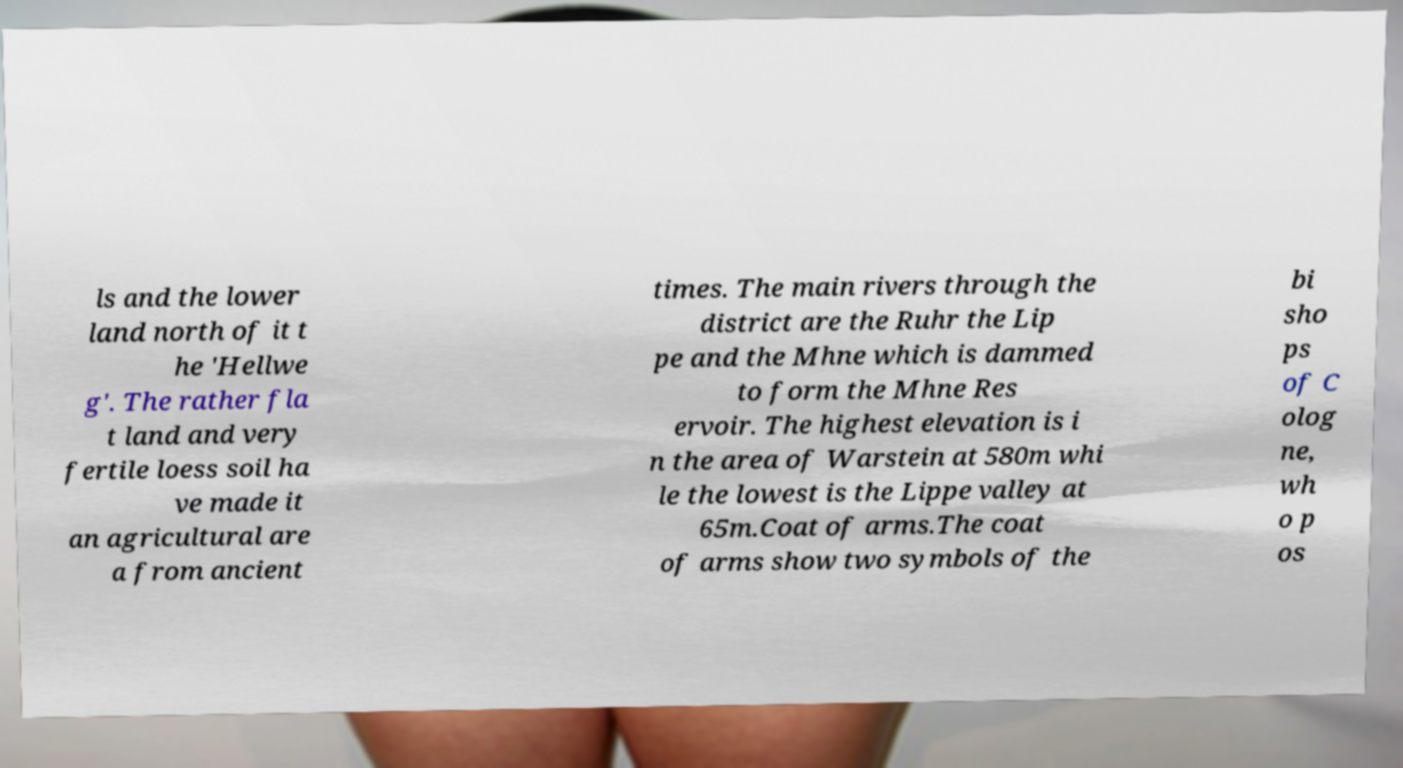Could you assist in decoding the text presented in this image and type it out clearly? ls and the lower land north of it t he 'Hellwe g'. The rather fla t land and very fertile loess soil ha ve made it an agricultural are a from ancient times. The main rivers through the district are the Ruhr the Lip pe and the Mhne which is dammed to form the Mhne Res ervoir. The highest elevation is i n the area of Warstein at 580m whi le the lowest is the Lippe valley at 65m.Coat of arms.The coat of arms show two symbols of the bi sho ps of C olog ne, wh o p os 